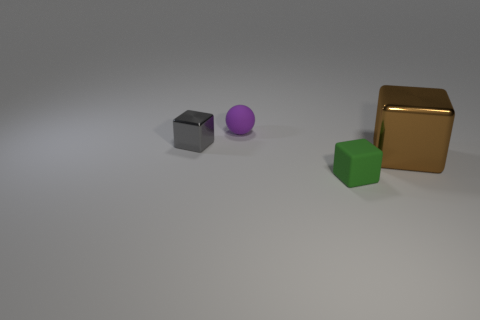What is the shape of the matte object that is behind the shiny block that is to the left of the green matte object?
Your answer should be compact. Sphere. Are there any other things that are the same color as the small rubber ball?
Your response must be concise. No. Is there a small thing behind the metal object left of the thing that is behind the small shiny cube?
Give a very brief answer. Yes. Does the shiny cube that is right of the small rubber cube have the same color as the small rubber thing in front of the small sphere?
Ensure brevity in your answer.  No. What material is the ball that is the same size as the gray block?
Keep it short and to the point. Rubber. There is a shiny object that is left of the tiny rubber object in front of the matte object that is to the left of the green matte block; how big is it?
Your response must be concise. Small. What number of other objects are there of the same material as the tiny purple object?
Your answer should be very brief. 1. There is a thing on the left side of the matte ball; how big is it?
Your answer should be compact. Small. How many shiny cubes are behind the brown cube and on the right side of the tiny sphere?
Your answer should be compact. 0. The small object behind the shiny block that is left of the brown shiny cube is made of what material?
Offer a very short reply. Rubber. 